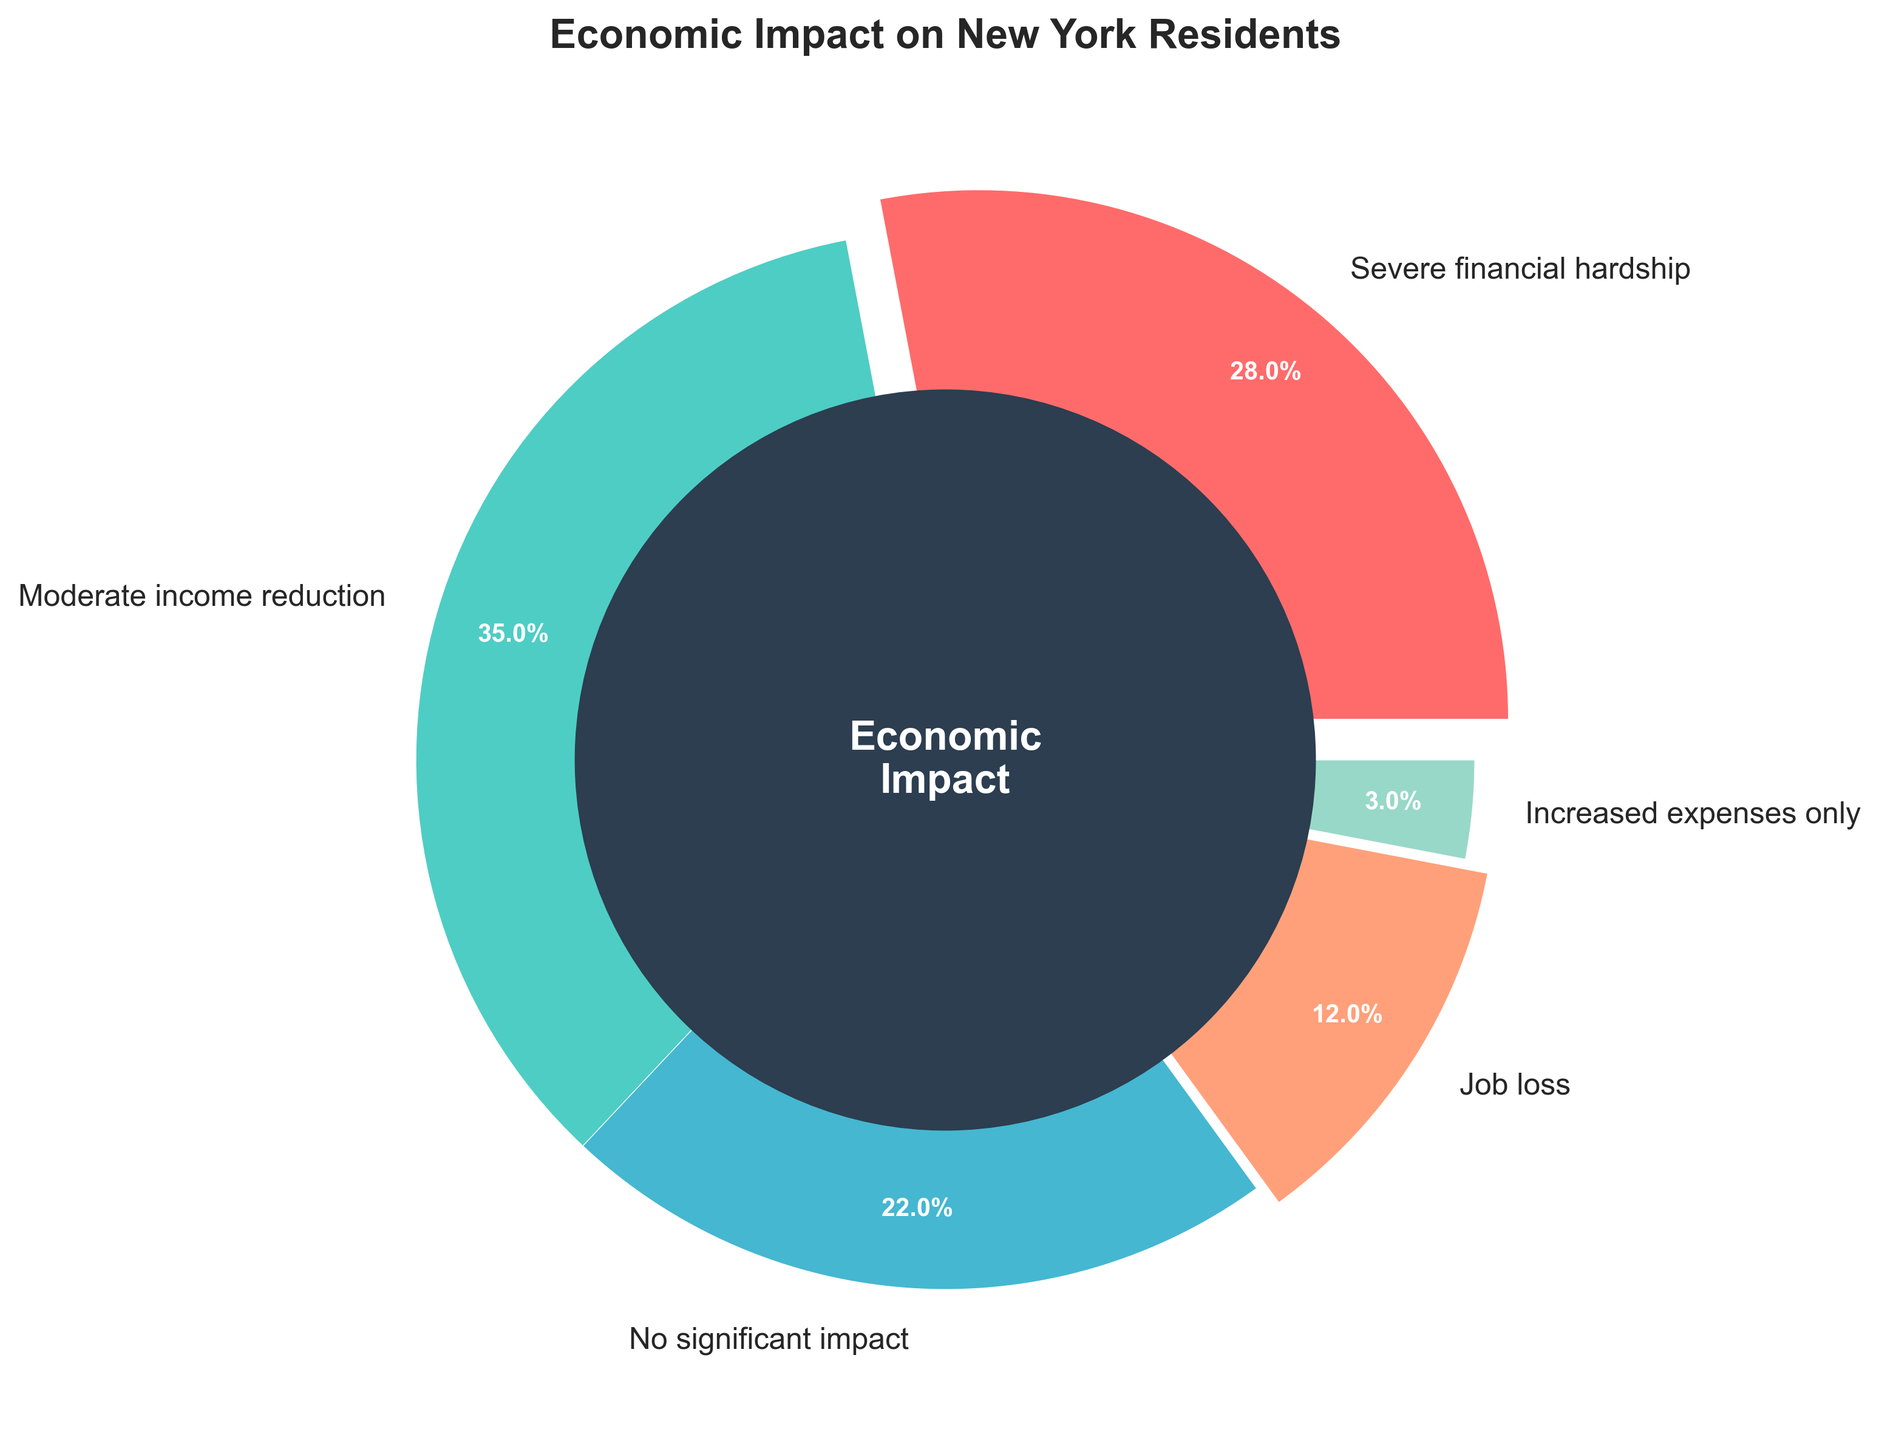What percentage of New York residents experienced severe financial hardship due to the crisis? Look for the segment labeled "Severe financial hardship" on the pie chart and note the percentage indicated.
Answer: 28% What is the combined percentage of residents who faced moderate income reduction and job loss? Identify the percentages for "Moderate income reduction" (35%) and "Job loss" (12%), then sum them up: 35% + 12% = 47%.
Answer: 47% Which category has more impact, severe financial hardship or increased expenses only? Compare the percentages of "Severe financial hardship" (28%) and "Increased expenses only" (3%). "Severe financial hardship" has a higher percentage.
Answer: Severe financial hardship Which two categories have the smallest impact on residents? Identify the two smallest segments in the pie chart. The smallest percentages are "Increased expenses only" (3%) and "Job loss" (12%).
Answer: Increased expenses only and Job loss How much higher is the percentage of residents experiencing moderate income reduction compared to those with no significant impact? Subtract the percentage for "No significant impact" (22%) from "Moderate income reduction" (35%): 35% - 22% = 13%.
Answer: 13% What portion of the residents did not face severe financial hardship or moderate income reduction? Calculate the combined percentage of the remaining categories: 100% - (28% + 35%) = 37%.
Answer: 37% Which color represents the category of increased expenses only? Visually identify the segment labeled "Increased expenses only" and observe the color. It is depicted in light blue.
Answer: Light blue How does the percentage of residents facing severe financial hardship compare to those with no significant impact? Identify the percentages: "Severe financial hardship" (28%) and "No significant impact" (22%). 28% > 22%, indicating a greater proportion of residents experiencing severe financial hardship.
Answer: Severe financial hardship is higher What is the total percentage of residents facing either job loss or severe financial hardship? Sum the percentages for "Job loss" (12%) and "Severe financial hardship" (28%): 12% + 28% = 40%.
Answer: 40% 